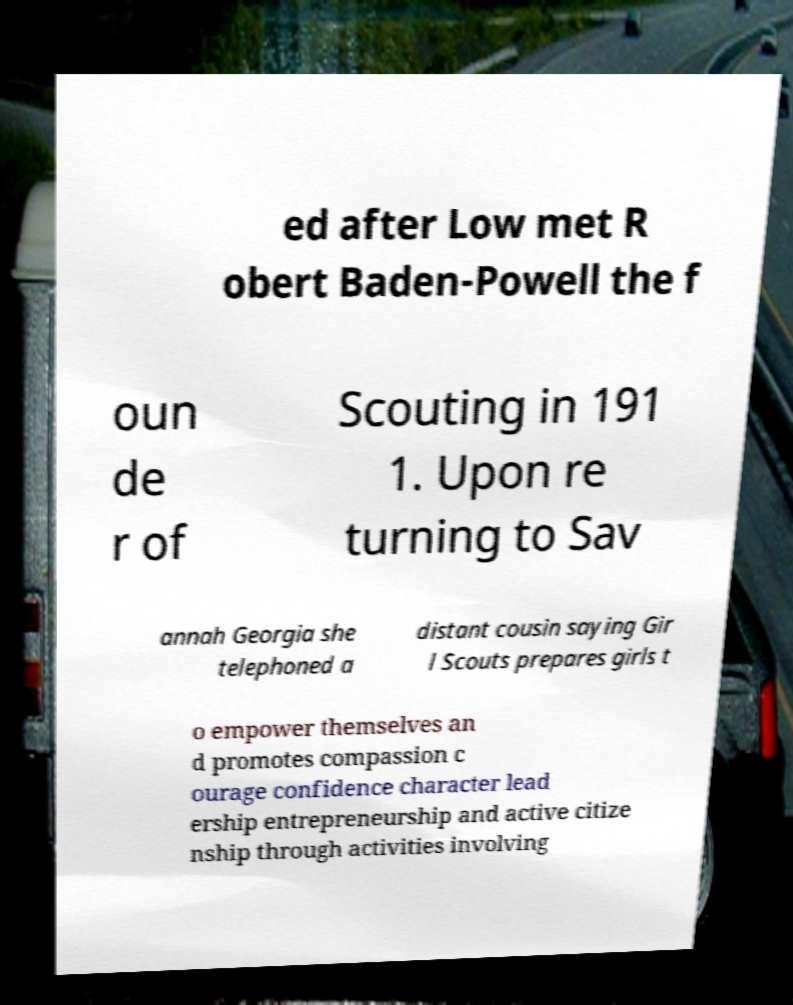What messages or text are displayed in this image? I need them in a readable, typed format. ed after Low met R obert Baden-Powell the f oun de r of Scouting in 191 1. Upon re turning to Sav annah Georgia she telephoned a distant cousin saying Gir l Scouts prepares girls t o empower themselves an d promotes compassion c ourage confidence character lead ership entrepreneurship and active citize nship through activities involving 